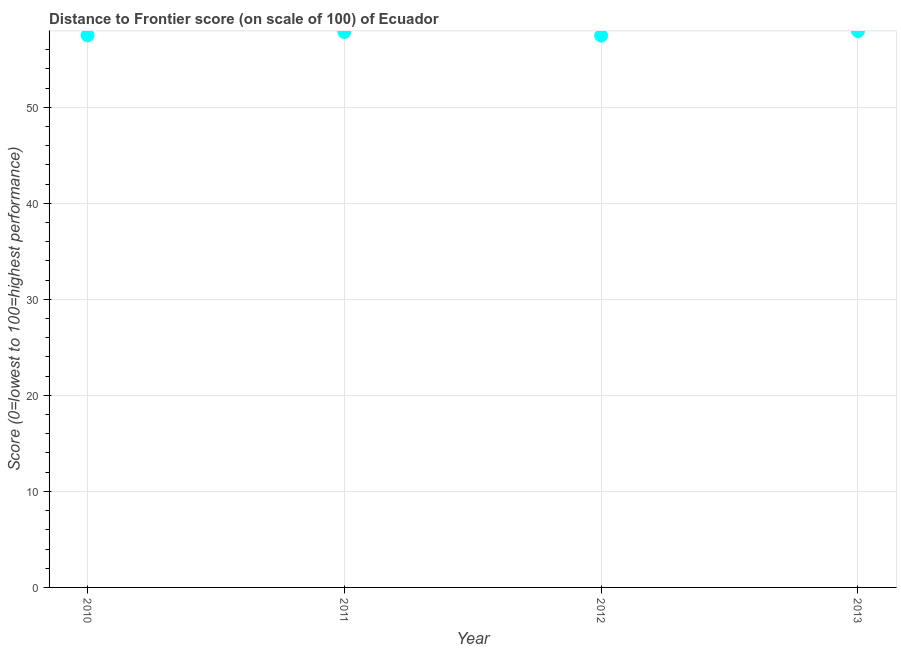What is the distance to frontier score in 2012?
Your answer should be very brief. 57.46. Across all years, what is the maximum distance to frontier score?
Give a very brief answer. 57.94. Across all years, what is the minimum distance to frontier score?
Offer a terse response. 57.46. In which year was the distance to frontier score minimum?
Offer a terse response. 2012. What is the sum of the distance to frontier score?
Offer a terse response. 230.73. What is the difference between the distance to frontier score in 2010 and 2013?
Give a very brief answer. -0.45. What is the average distance to frontier score per year?
Provide a short and direct response. 57.68. What is the median distance to frontier score?
Offer a very short reply. 57.67. In how many years, is the distance to frontier score greater than 24 ?
Provide a succinct answer. 4. What is the ratio of the distance to frontier score in 2010 to that in 2012?
Give a very brief answer. 1. Is the difference between the distance to frontier score in 2010 and 2012 greater than the difference between any two years?
Your response must be concise. No. What is the difference between the highest and the second highest distance to frontier score?
Your answer should be compact. 0.1. Is the sum of the distance to frontier score in 2012 and 2013 greater than the maximum distance to frontier score across all years?
Offer a very short reply. Yes. What is the difference between the highest and the lowest distance to frontier score?
Make the answer very short. 0.48. In how many years, is the distance to frontier score greater than the average distance to frontier score taken over all years?
Provide a short and direct response. 2. Does the distance to frontier score monotonically increase over the years?
Give a very brief answer. No. How many dotlines are there?
Give a very brief answer. 1. How many years are there in the graph?
Provide a succinct answer. 4. Are the values on the major ticks of Y-axis written in scientific E-notation?
Your answer should be compact. No. What is the title of the graph?
Your answer should be very brief. Distance to Frontier score (on scale of 100) of Ecuador. What is the label or title of the X-axis?
Provide a short and direct response. Year. What is the label or title of the Y-axis?
Ensure brevity in your answer.  Score (0=lowest to 100=highest performance). What is the Score (0=lowest to 100=highest performance) in 2010?
Give a very brief answer. 57.49. What is the Score (0=lowest to 100=highest performance) in 2011?
Ensure brevity in your answer.  57.84. What is the Score (0=lowest to 100=highest performance) in 2012?
Your answer should be compact. 57.46. What is the Score (0=lowest to 100=highest performance) in 2013?
Your response must be concise. 57.94. What is the difference between the Score (0=lowest to 100=highest performance) in 2010 and 2011?
Make the answer very short. -0.35. What is the difference between the Score (0=lowest to 100=highest performance) in 2010 and 2013?
Your answer should be very brief. -0.45. What is the difference between the Score (0=lowest to 100=highest performance) in 2011 and 2012?
Keep it short and to the point. 0.38. What is the difference between the Score (0=lowest to 100=highest performance) in 2012 and 2013?
Provide a succinct answer. -0.48. What is the ratio of the Score (0=lowest to 100=highest performance) in 2010 to that in 2013?
Your answer should be very brief. 0.99. What is the ratio of the Score (0=lowest to 100=highest performance) in 2011 to that in 2012?
Make the answer very short. 1.01. What is the ratio of the Score (0=lowest to 100=highest performance) in 2011 to that in 2013?
Give a very brief answer. 1. 